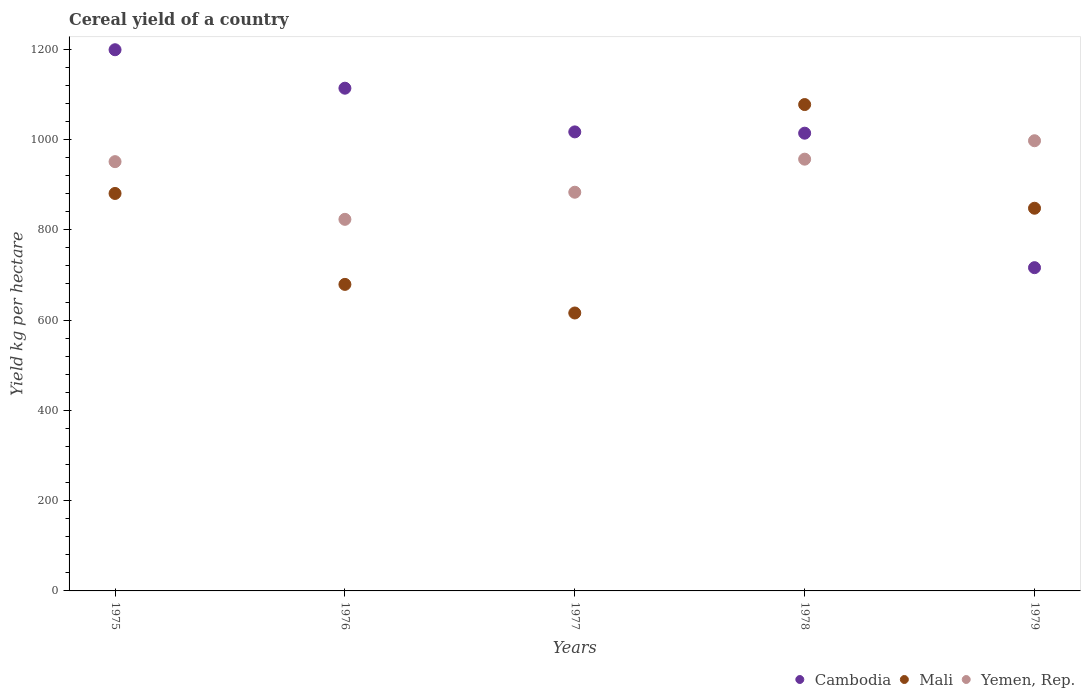What is the total cereal yield in Cambodia in 1978?
Your response must be concise. 1014.09. Across all years, what is the maximum total cereal yield in Cambodia?
Ensure brevity in your answer.  1198.95. Across all years, what is the minimum total cereal yield in Cambodia?
Offer a very short reply. 716.14. In which year was the total cereal yield in Mali maximum?
Your response must be concise. 1978. In which year was the total cereal yield in Mali minimum?
Your answer should be very brief. 1977. What is the total total cereal yield in Cambodia in the graph?
Offer a very short reply. 5059.87. What is the difference between the total cereal yield in Mali in 1978 and that in 1979?
Offer a very short reply. 229.7. What is the difference between the total cereal yield in Cambodia in 1979 and the total cereal yield in Yemen, Rep. in 1977?
Ensure brevity in your answer.  -167.15. What is the average total cereal yield in Mali per year?
Ensure brevity in your answer.  820.14. In the year 1978, what is the difference between the total cereal yield in Yemen, Rep. and total cereal yield in Cambodia?
Give a very brief answer. -57.57. What is the ratio of the total cereal yield in Cambodia in 1976 to that in 1978?
Make the answer very short. 1.1. Is the total cereal yield in Cambodia in 1977 less than that in 1979?
Offer a terse response. No. What is the difference between the highest and the second highest total cereal yield in Yemen, Rep.?
Make the answer very short. 40.83. What is the difference between the highest and the lowest total cereal yield in Mali?
Your answer should be compact. 461.79. Is the sum of the total cereal yield in Mali in 1978 and 1979 greater than the maximum total cereal yield in Cambodia across all years?
Your response must be concise. Yes. Does the total cereal yield in Mali monotonically increase over the years?
Provide a short and direct response. No. Is the total cereal yield in Mali strictly greater than the total cereal yield in Cambodia over the years?
Your response must be concise. No. How many years are there in the graph?
Make the answer very short. 5. What is the difference between two consecutive major ticks on the Y-axis?
Ensure brevity in your answer.  200. Are the values on the major ticks of Y-axis written in scientific E-notation?
Give a very brief answer. No. Does the graph contain grids?
Make the answer very short. No. How many legend labels are there?
Provide a short and direct response. 3. What is the title of the graph?
Keep it short and to the point. Cereal yield of a country. Does "Lebanon" appear as one of the legend labels in the graph?
Make the answer very short. No. What is the label or title of the Y-axis?
Keep it short and to the point. Yield kg per hectare. What is the Yield kg per hectare in Cambodia in 1975?
Offer a terse response. 1198.95. What is the Yield kg per hectare of Mali in 1975?
Your answer should be compact. 880.55. What is the Yield kg per hectare in Yemen, Rep. in 1975?
Offer a very short reply. 951.02. What is the Yield kg per hectare of Cambodia in 1976?
Provide a short and direct response. 1113.74. What is the Yield kg per hectare of Mali in 1976?
Make the answer very short. 679.11. What is the Yield kg per hectare in Yemen, Rep. in 1976?
Keep it short and to the point. 823.2. What is the Yield kg per hectare of Cambodia in 1977?
Make the answer very short. 1016.95. What is the Yield kg per hectare in Mali in 1977?
Offer a very short reply. 615.73. What is the Yield kg per hectare of Yemen, Rep. in 1977?
Keep it short and to the point. 883.29. What is the Yield kg per hectare of Cambodia in 1978?
Give a very brief answer. 1014.09. What is the Yield kg per hectare of Mali in 1978?
Offer a very short reply. 1077.52. What is the Yield kg per hectare in Yemen, Rep. in 1978?
Provide a short and direct response. 956.52. What is the Yield kg per hectare in Cambodia in 1979?
Keep it short and to the point. 716.14. What is the Yield kg per hectare in Mali in 1979?
Make the answer very short. 847.81. What is the Yield kg per hectare in Yemen, Rep. in 1979?
Your answer should be very brief. 997.34. Across all years, what is the maximum Yield kg per hectare of Cambodia?
Provide a short and direct response. 1198.95. Across all years, what is the maximum Yield kg per hectare of Mali?
Keep it short and to the point. 1077.52. Across all years, what is the maximum Yield kg per hectare in Yemen, Rep.?
Your response must be concise. 997.34. Across all years, what is the minimum Yield kg per hectare in Cambodia?
Offer a very short reply. 716.14. Across all years, what is the minimum Yield kg per hectare of Mali?
Ensure brevity in your answer.  615.73. Across all years, what is the minimum Yield kg per hectare in Yemen, Rep.?
Provide a short and direct response. 823.2. What is the total Yield kg per hectare in Cambodia in the graph?
Offer a very short reply. 5059.87. What is the total Yield kg per hectare of Mali in the graph?
Give a very brief answer. 4100.72. What is the total Yield kg per hectare in Yemen, Rep. in the graph?
Provide a succinct answer. 4611.38. What is the difference between the Yield kg per hectare in Cambodia in 1975 and that in 1976?
Make the answer very short. 85.21. What is the difference between the Yield kg per hectare in Mali in 1975 and that in 1976?
Ensure brevity in your answer.  201.44. What is the difference between the Yield kg per hectare in Yemen, Rep. in 1975 and that in 1976?
Keep it short and to the point. 127.82. What is the difference between the Yield kg per hectare of Cambodia in 1975 and that in 1977?
Offer a very short reply. 182. What is the difference between the Yield kg per hectare in Mali in 1975 and that in 1977?
Your response must be concise. 264.82. What is the difference between the Yield kg per hectare in Yemen, Rep. in 1975 and that in 1977?
Ensure brevity in your answer.  67.73. What is the difference between the Yield kg per hectare of Cambodia in 1975 and that in 1978?
Ensure brevity in your answer.  184.87. What is the difference between the Yield kg per hectare in Mali in 1975 and that in 1978?
Keep it short and to the point. -196.96. What is the difference between the Yield kg per hectare in Yemen, Rep. in 1975 and that in 1978?
Offer a very short reply. -5.49. What is the difference between the Yield kg per hectare of Cambodia in 1975 and that in 1979?
Make the answer very short. 482.82. What is the difference between the Yield kg per hectare of Mali in 1975 and that in 1979?
Your answer should be very brief. 32.74. What is the difference between the Yield kg per hectare of Yemen, Rep. in 1975 and that in 1979?
Provide a succinct answer. -46.32. What is the difference between the Yield kg per hectare of Cambodia in 1976 and that in 1977?
Your response must be concise. 96.8. What is the difference between the Yield kg per hectare in Mali in 1976 and that in 1977?
Provide a succinct answer. 63.38. What is the difference between the Yield kg per hectare of Yemen, Rep. in 1976 and that in 1977?
Provide a succinct answer. -60.09. What is the difference between the Yield kg per hectare of Cambodia in 1976 and that in 1978?
Make the answer very short. 99.66. What is the difference between the Yield kg per hectare in Mali in 1976 and that in 1978?
Give a very brief answer. -398.41. What is the difference between the Yield kg per hectare in Yemen, Rep. in 1976 and that in 1978?
Provide a short and direct response. -133.31. What is the difference between the Yield kg per hectare of Cambodia in 1976 and that in 1979?
Provide a succinct answer. 397.61. What is the difference between the Yield kg per hectare in Mali in 1976 and that in 1979?
Offer a very short reply. -168.7. What is the difference between the Yield kg per hectare of Yemen, Rep. in 1976 and that in 1979?
Keep it short and to the point. -174.14. What is the difference between the Yield kg per hectare of Cambodia in 1977 and that in 1978?
Give a very brief answer. 2.86. What is the difference between the Yield kg per hectare of Mali in 1977 and that in 1978?
Offer a very short reply. -461.79. What is the difference between the Yield kg per hectare of Yemen, Rep. in 1977 and that in 1978?
Provide a succinct answer. -73.22. What is the difference between the Yield kg per hectare in Cambodia in 1977 and that in 1979?
Give a very brief answer. 300.81. What is the difference between the Yield kg per hectare of Mali in 1977 and that in 1979?
Your answer should be compact. -232.09. What is the difference between the Yield kg per hectare in Yemen, Rep. in 1977 and that in 1979?
Provide a short and direct response. -114.05. What is the difference between the Yield kg per hectare in Cambodia in 1978 and that in 1979?
Ensure brevity in your answer.  297.95. What is the difference between the Yield kg per hectare of Mali in 1978 and that in 1979?
Keep it short and to the point. 229.7. What is the difference between the Yield kg per hectare in Yemen, Rep. in 1978 and that in 1979?
Offer a very short reply. -40.83. What is the difference between the Yield kg per hectare in Cambodia in 1975 and the Yield kg per hectare in Mali in 1976?
Provide a short and direct response. 519.84. What is the difference between the Yield kg per hectare of Cambodia in 1975 and the Yield kg per hectare of Yemen, Rep. in 1976?
Your answer should be very brief. 375.75. What is the difference between the Yield kg per hectare of Mali in 1975 and the Yield kg per hectare of Yemen, Rep. in 1976?
Your answer should be very brief. 57.35. What is the difference between the Yield kg per hectare in Cambodia in 1975 and the Yield kg per hectare in Mali in 1977?
Offer a very short reply. 583.23. What is the difference between the Yield kg per hectare of Cambodia in 1975 and the Yield kg per hectare of Yemen, Rep. in 1977?
Ensure brevity in your answer.  315.66. What is the difference between the Yield kg per hectare in Mali in 1975 and the Yield kg per hectare in Yemen, Rep. in 1977?
Offer a terse response. -2.74. What is the difference between the Yield kg per hectare in Cambodia in 1975 and the Yield kg per hectare in Mali in 1978?
Keep it short and to the point. 121.44. What is the difference between the Yield kg per hectare in Cambodia in 1975 and the Yield kg per hectare in Yemen, Rep. in 1978?
Offer a very short reply. 242.44. What is the difference between the Yield kg per hectare of Mali in 1975 and the Yield kg per hectare of Yemen, Rep. in 1978?
Your answer should be very brief. -75.96. What is the difference between the Yield kg per hectare of Cambodia in 1975 and the Yield kg per hectare of Mali in 1979?
Give a very brief answer. 351.14. What is the difference between the Yield kg per hectare in Cambodia in 1975 and the Yield kg per hectare in Yemen, Rep. in 1979?
Offer a terse response. 201.61. What is the difference between the Yield kg per hectare in Mali in 1975 and the Yield kg per hectare in Yemen, Rep. in 1979?
Provide a short and direct response. -116.79. What is the difference between the Yield kg per hectare in Cambodia in 1976 and the Yield kg per hectare in Mali in 1977?
Ensure brevity in your answer.  498.02. What is the difference between the Yield kg per hectare of Cambodia in 1976 and the Yield kg per hectare of Yemen, Rep. in 1977?
Your answer should be very brief. 230.45. What is the difference between the Yield kg per hectare in Mali in 1976 and the Yield kg per hectare in Yemen, Rep. in 1977?
Make the answer very short. -204.18. What is the difference between the Yield kg per hectare of Cambodia in 1976 and the Yield kg per hectare of Mali in 1978?
Offer a terse response. 36.23. What is the difference between the Yield kg per hectare of Cambodia in 1976 and the Yield kg per hectare of Yemen, Rep. in 1978?
Offer a very short reply. 157.23. What is the difference between the Yield kg per hectare of Mali in 1976 and the Yield kg per hectare of Yemen, Rep. in 1978?
Your answer should be compact. -277.41. What is the difference between the Yield kg per hectare of Cambodia in 1976 and the Yield kg per hectare of Mali in 1979?
Give a very brief answer. 265.93. What is the difference between the Yield kg per hectare in Cambodia in 1976 and the Yield kg per hectare in Yemen, Rep. in 1979?
Provide a short and direct response. 116.4. What is the difference between the Yield kg per hectare in Mali in 1976 and the Yield kg per hectare in Yemen, Rep. in 1979?
Your answer should be very brief. -318.23. What is the difference between the Yield kg per hectare in Cambodia in 1977 and the Yield kg per hectare in Mali in 1978?
Give a very brief answer. -60.57. What is the difference between the Yield kg per hectare of Cambodia in 1977 and the Yield kg per hectare of Yemen, Rep. in 1978?
Your response must be concise. 60.43. What is the difference between the Yield kg per hectare of Mali in 1977 and the Yield kg per hectare of Yemen, Rep. in 1978?
Give a very brief answer. -340.79. What is the difference between the Yield kg per hectare in Cambodia in 1977 and the Yield kg per hectare in Mali in 1979?
Your response must be concise. 169.14. What is the difference between the Yield kg per hectare of Cambodia in 1977 and the Yield kg per hectare of Yemen, Rep. in 1979?
Your response must be concise. 19.61. What is the difference between the Yield kg per hectare of Mali in 1977 and the Yield kg per hectare of Yemen, Rep. in 1979?
Your response must be concise. -381.62. What is the difference between the Yield kg per hectare of Cambodia in 1978 and the Yield kg per hectare of Mali in 1979?
Ensure brevity in your answer.  166.27. What is the difference between the Yield kg per hectare in Cambodia in 1978 and the Yield kg per hectare in Yemen, Rep. in 1979?
Your answer should be very brief. 16.74. What is the difference between the Yield kg per hectare of Mali in 1978 and the Yield kg per hectare of Yemen, Rep. in 1979?
Provide a succinct answer. 80.17. What is the average Yield kg per hectare of Cambodia per year?
Keep it short and to the point. 1011.97. What is the average Yield kg per hectare in Mali per year?
Give a very brief answer. 820.14. What is the average Yield kg per hectare in Yemen, Rep. per year?
Provide a succinct answer. 922.28. In the year 1975, what is the difference between the Yield kg per hectare in Cambodia and Yield kg per hectare in Mali?
Ensure brevity in your answer.  318.4. In the year 1975, what is the difference between the Yield kg per hectare in Cambodia and Yield kg per hectare in Yemen, Rep.?
Make the answer very short. 247.93. In the year 1975, what is the difference between the Yield kg per hectare of Mali and Yield kg per hectare of Yemen, Rep.?
Offer a very short reply. -70.47. In the year 1976, what is the difference between the Yield kg per hectare in Cambodia and Yield kg per hectare in Mali?
Ensure brevity in your answer.  434.63. In the year 1976, what is the difference between the Yield kg per hectare of Cambodia and Yield kg per hectare of Yemen, Rep.?
Your answer should be compact. 290.54. In the year 1976, what is the difference between the Yield kg per hectare in Mali and Yield kg per hectare in Yemen, Rep.?
Provide a succinct answer. -144.09. In the year 1977, what is the difference between the Yield kg per hectare of Cambodia and Yield kg per hectare of Mali?
Offer a terse response. 401.22. In the year 1977, what is the difference between the Yield kg per hectare of Cambodia and Yield kg per hectare of Yemen, Rep.?
Ensure brevity in your answer.  133.66. In the year 1977, what is the difference between the Yield kg per hectare in Mali and Yield kg per hectare in Yemen, Rep.?
Your answer should be compact. -267.56. In the year 1978, what is the difference between the Yield kg per hectare of Cambodia and Yield kg per hectare of Mali?
Keep it short and to the point. -63.43. In the year 1978, what is the difference between the Yield kg per hectare in Cambodia and Yield kg per hectare in Yemen, Rep.?
Give a very brief answer. 57.57. In the year 1978, what is the difference between the Yield kg per hectare in Mali and Yield kg per hectare in Yemen, Rep.?
Provide a succinct answer. 121. In the year 1979, what is the difference between the Yield kg per hectare of Cambodia and Yield kg per hectare of Mali?
Make the answer very short. -131.68. In the year 1979, what is the difference between the Yield kg per hectare of Cambodia and Yield kg per hectare of Yemen, Rep.?
Keep it short and to the point. -281.21. In the year 1979, what is the difference between the Yield kg per hectare in Mali and Yield kg per hectare in Yemen, Rep.?
Make the answer very short. -149.53. What is the ratio of the Yield kg per hectare of Cambodia in 1975 to that in 1976?
Your answer should be compact. 1.08. What is the ratio of the Yield kg per hectare of Mali in 1975 to that in 1976?
Ensure brevity in your answer.  1.3. What is the ratio of the Yield kg per hectare in Yemen, Rep. in 1975 to that in 1976?
Give a very brief answer. 1.16. What is the ratio of the Yield kg per hectare of Cambodia in 1975 to that in 1977?
Offer a terse response. 1.18. What is the ratio of the Yield kg per hectare of Mali in 1975 to that in 1977?
Keep it short and to the point. 1.43. What is the ratio of the Yield kg per hectare of Yemen, Rep. in 1975 to that in 1977?
Your answer should be compact. 1.08. What is the ratio of the Yield kg per hectare of Cambodia in 1975 to that in 1978?
Your answer should be compact. 1.18. What is the ratio of the Yield kg per hectare in Mali in 1975 to that in 1978?
Make the answer very short. 0.82. What is the ratio of the Yield kg per hectare in Yemen, Rep. in 1975 to that in 1978?
Your answer should be very brief. 0.99. What is the ratio of the Yield kg per hectare in Cambodia in 1975 to that in 1979?
Offer a terse response. 1.67. What is the ratio of the Yield kg per hectare of Mali in 1975 to that in 1979?
Keep it short and to the point. 1.04. What is the ratio of the Yield kg per hectare in Yemen, Rep. in 1975 to that in 1979?
Keep it short and to the point. 0.95. What is the ratio of the Yield kg per hectare of Cambodia in 1976 to that in 1977?
Provide a short and direct response. 1.1. What is the ratio of the Yield kg per hectare in Mali in 1976 to that in 1977?
Your answer should be compact. 1.1. What is the ratio of the Yield kg per hectare in Yemen, Rep. in 1976 to that in 1977?
Make the answer very short. 0.93. What is the ratio of the Yield kg per hectare of Cambodia in 1976 to that in 1978?
Make the answer very short. 1.1. What is the ratio of the Yield kg per hectare of Mali in 1976 to that in 1978?
Make the answer very short. 0.63. What is the ratio of the Yield kg per hectare of Yemen, Rep. in 1976 to that in 1978?
Provide a succinct answer. 0.86. What is the ratio of the Yield kg per hectare of Cambodia in 1976 to that in 1979?
Your answer should be compact. 1.56. What is the ratio of the Yield kg per hectare in Mali in 1976 to that in 1979?
Make the answer very short. 0.8. What is the ratio of the Yield kg per hectare of Yemen, Rep. in 1976 to that in 1979?
Your response must be concise. 0.83. What is the ratio of the Yield kg per hectare in Yemen, Rep. in 1977 to that in 1978?
Keep it short and to the point. 0.92. What is the ratio of the Yield kg per hectare of Cambodia in 1977 to that in 1979?
Keep it short and to the point. 1.42. What is the ratio of the Yield kg per hectare in Mali in 1977 to that in 1979?
Offer a very short reply. 0.73. What is the ratio of the Yield kg per hectare in Yemen, Rep. in 1977 to that in 1979?
Keep it short and to the point. 0.89. What is the ratio of the Yield kg per hectare in Cambodia in 1978 to that in 1979?
Provide a short and direct response. 1.42. What is the ratio of the Yield kg per hectare in Mali in 1978 to that in 1979?
Give a very brief answer. 1.27. What is the ratio of the Yield kg per hectare in Yemen, Rep. in 1978 to that in 1979?
Your answer should be very brief. 0.96. What is the difference between the highest and the second highest Yield kg per hectare in Cambodia?
Provide a short and direct response. 85.21. What is the difference between the highest and the second highest Yield kg per hectare in Mali?
Your answer should be compact. 196.96. What is the difference between the highest and the second highest Yield kg per hectare of Yemen, Rep.?
Your response must be concise. 40.83. What is the difference between the highest and the lowest Yield kg per hectare of Cambodia?
Ensure brevity in your answer.  482.82. What is the difference between the highest and the lowest Yield kg per hectare in Mali?
Your answer should be compact. 461.79. What is the difference between the highest and the lowest Yield kg per hectare of Yemen, Rep.?
Give a very brief answer. 174.14. 